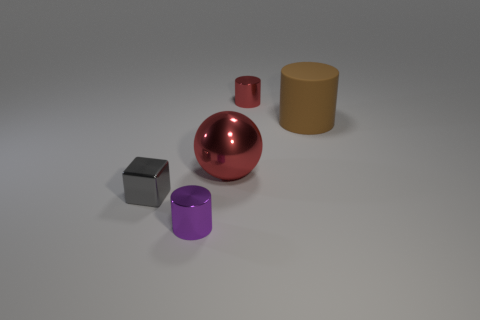Add 2 tiny yellow rubber objects. How many objects exist? 7 Subtract all balls. How many objects are left? 4 Subtract all large green metal things. Subtract all matte objects. How many objects are left? 4 Add 2 large things. How many large things are left? 4 Add 5 big red balls. How many big red balls exist? 6 Subtract 0 yellow blocks. How many objects are left? 5 